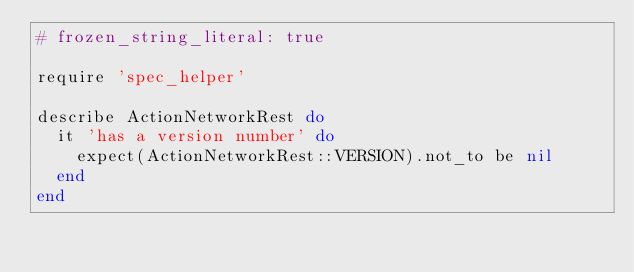Convert code to text. <code><loc_0><loc_0><loc_500><loc_500><_Ruby_># frozen_string_literal: true

require 'spec_helper'

describe ActionNetworkRest do
  it 'has a version number' do
    expect(ActionNetworkRest::VERSION).not_to be nil
  end
end
</code> 